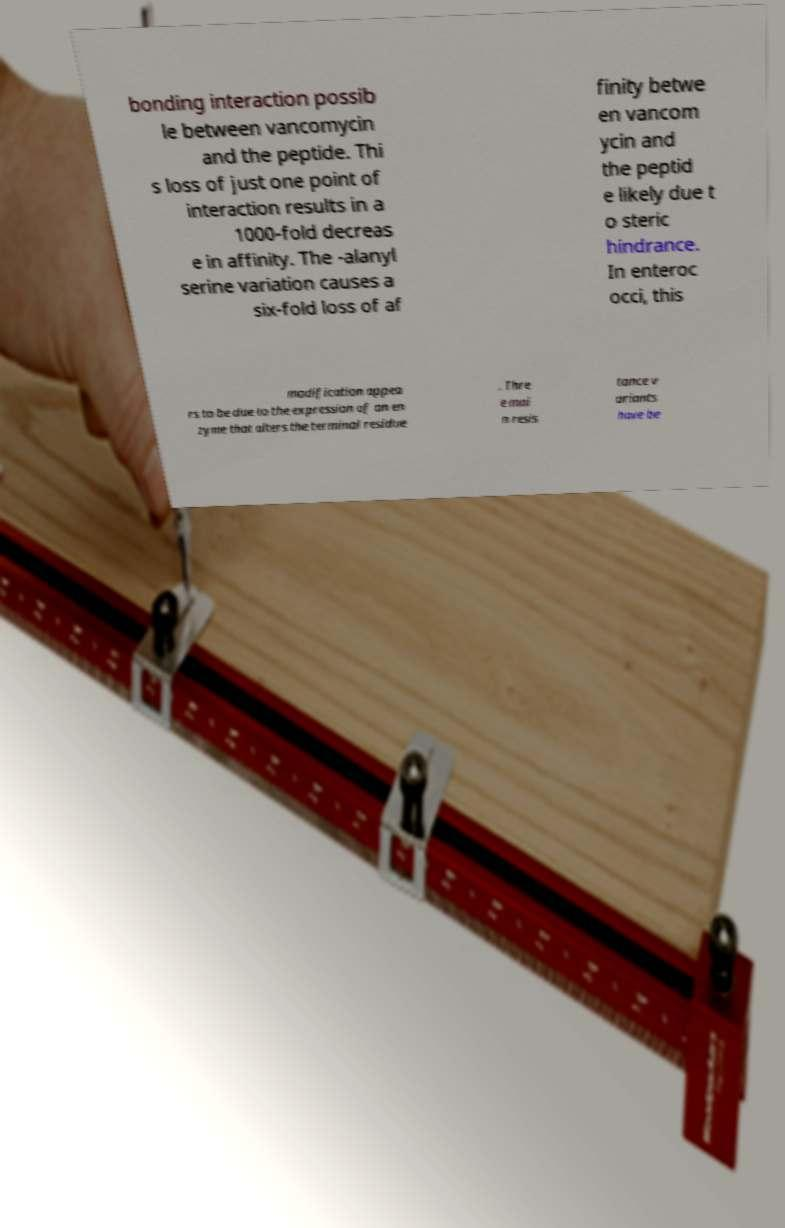Please read and relay the text visible in this image. What does it say? bonding interaction possib le between vancomycin and the peptide. Thi s loss of just one point of interaction results in a 1000-fold decreas e in affinity. The -alanyl serine variation causes a six-fold loss of af finity betwe en vancom ycin and the peptid e likely due t o steric hindrance. In enteroc occi, this modification appea rs to be due to the expression of an en zyme that alters the terminal residue . Thre e mai n resis tance v ariants have be 